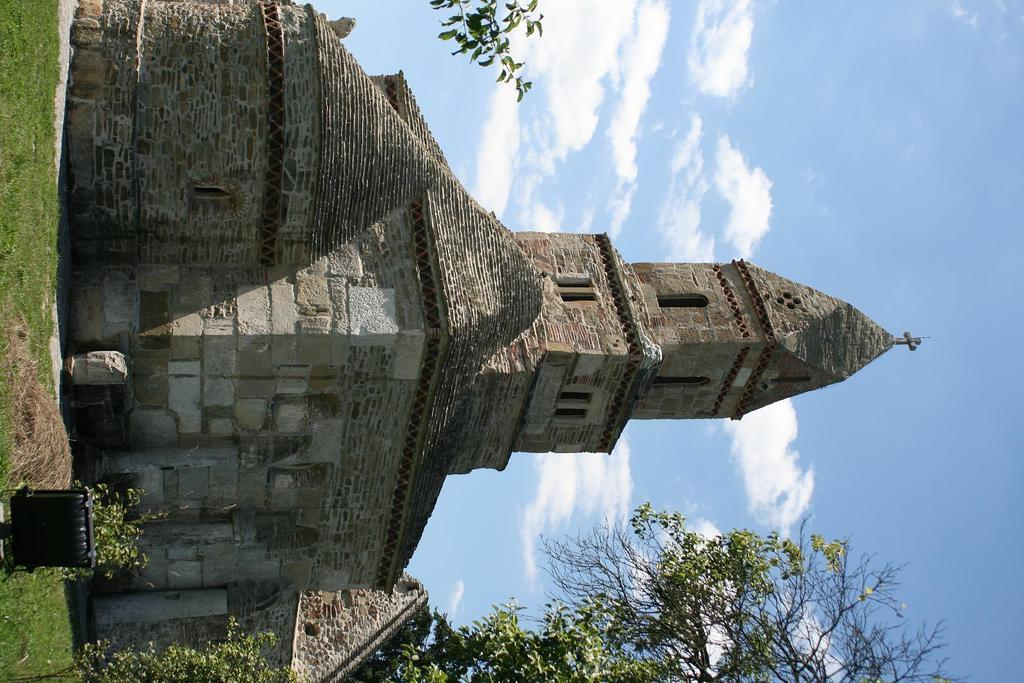What type of structure is in the image? There is a building in the image. What are some features of the building? The building has windows and brick walls. What is on the ground in the image? There is grass on the ground in the image. What else can be seen in the image besides the building? Branches of trees are visible in the image. What is visible in the background of the image? There is sky visible in the background of the image. What can be observed in the sky? Clouds are present in the sky. Can you see the alley behind the building in the image? There is no alley visible in the image; it only shows the building, grass, trees, and sky. What type of wrist accessory is the person wearing in the image? There are no people present in the image, so it is not possible to determine if anyone is wearing a wrist accessory. 